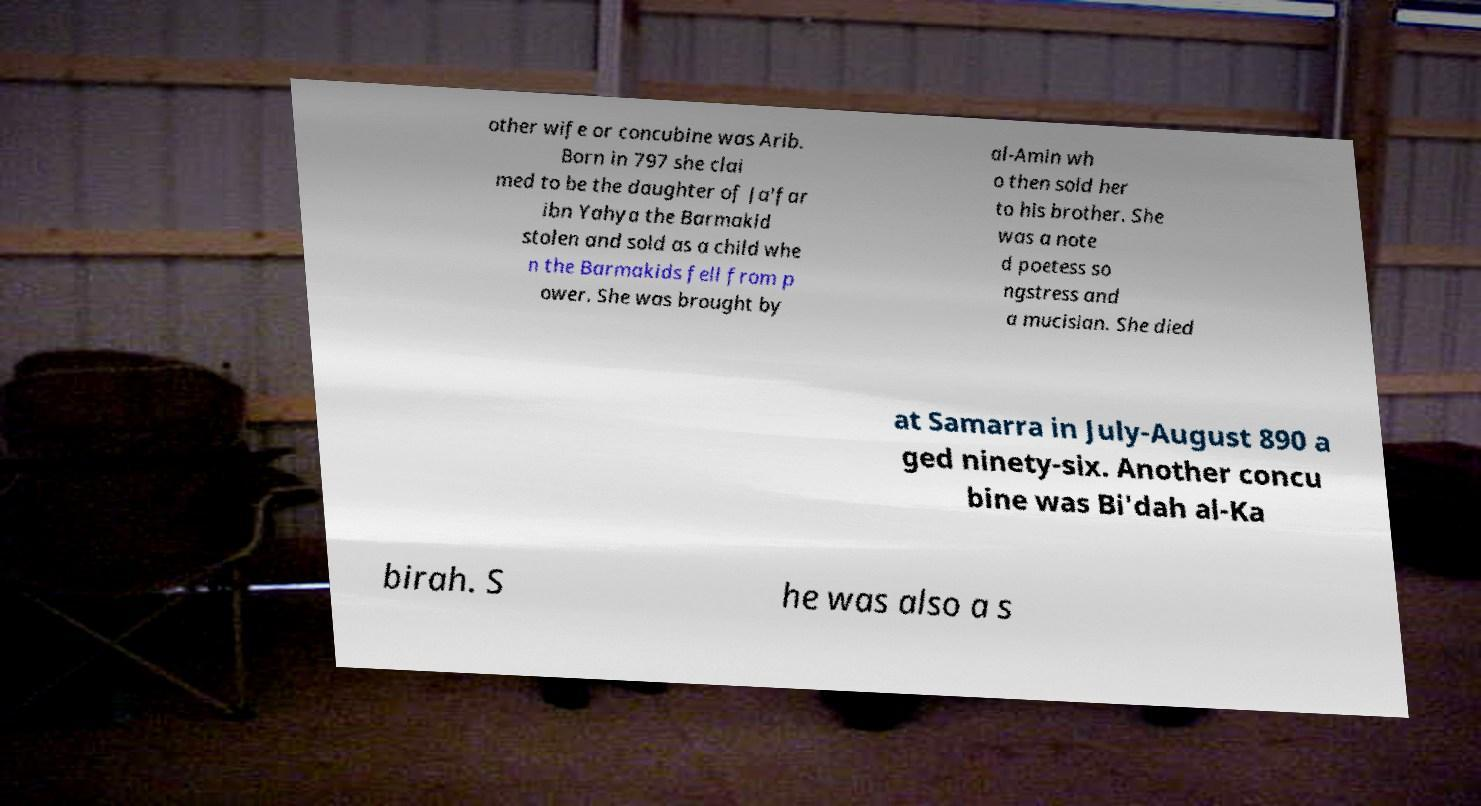Could you extract and type out the text from this image? other wife or concubine was Arib. Born in 797 she clai med to be the daughter of Ja'far ibn Yahya the Barmakid stolen and sold as a child whe n the Barmakids fell from p ower. She was brought by al-Amin wh o then sold her to his brother. She was a note d poetess so ngstress and a mucisian. She died at Samarra in July-August 890 a ged ninety-six. Another concu bine was Bi'dah al-Ka birah. S he was also a s 